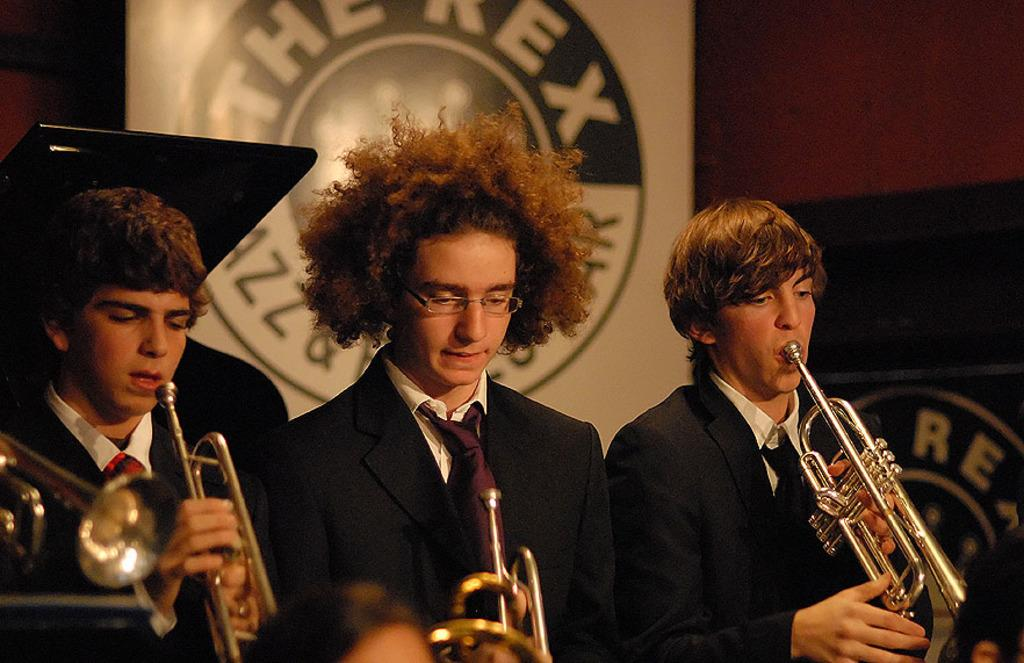How many people are in the image? There are three persons in the image. What are the people doing in the image? Each person is holding a musical instrument. Is there any text visible in the image? Yes, there is a board with text visible in the image. What type of toothbrush is each person using while playing their musical instruments? There is no toothbrush present in the image, and the people are not using any toothbrushes while playing their musical instruments. 